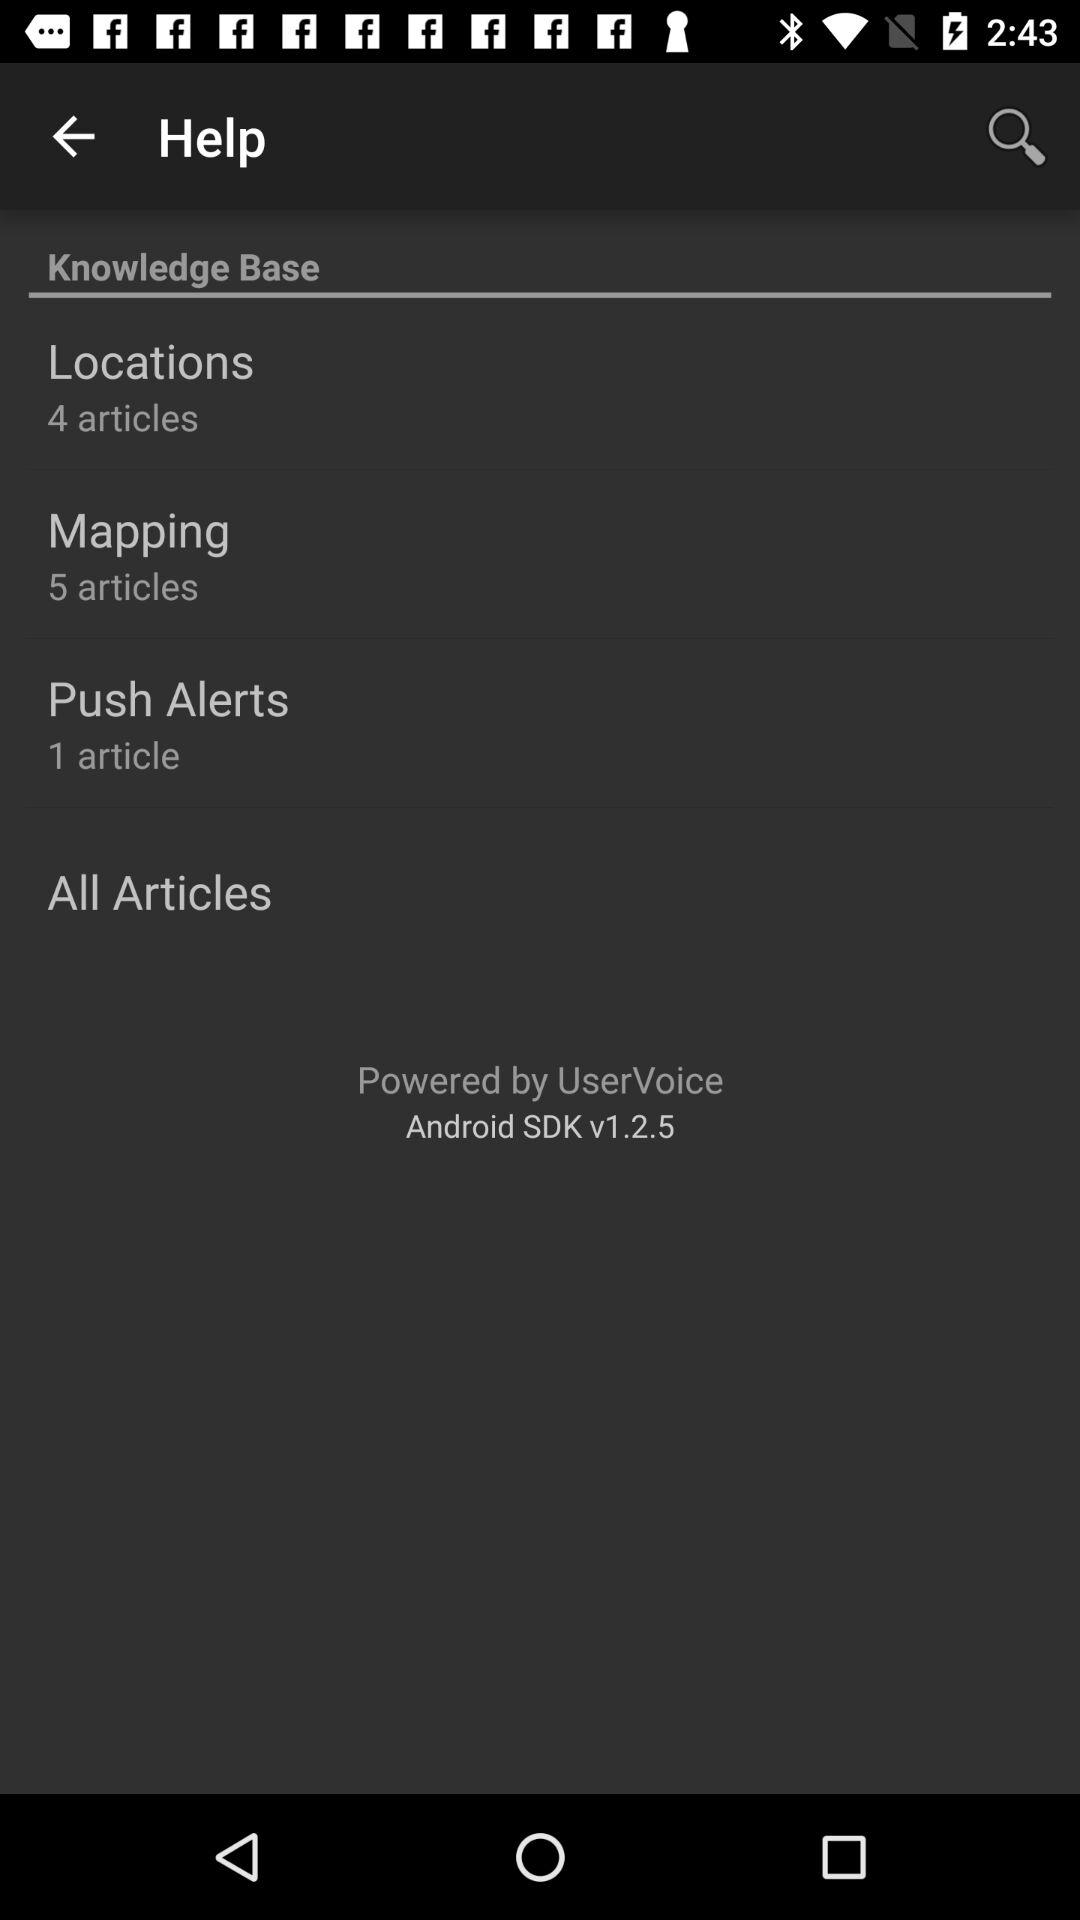This application is powered by whom? This application is powered by "UserVoice". 